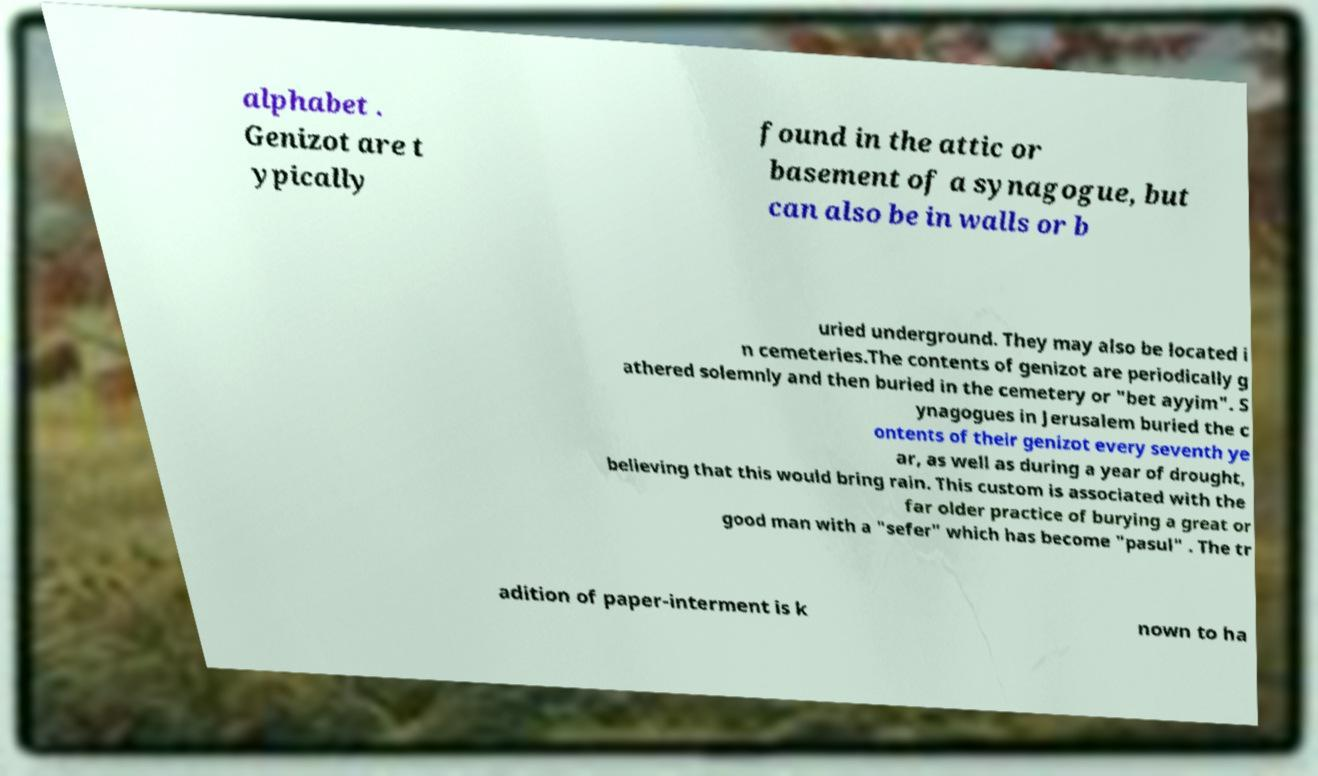Can you accurately transcribe the text from the provided image for me? alphabet . Genizot are t ypically found in the attic or basement of a synagogue, but can also be in walls or b uried underground. They may also be located i n cemeteries.The contents of genizot are periodically g athered solemnly and then buried in the cemetery or "bet ayyim". S ynagogues in Jerusalem buried the c ontents of their genizot every seventh ye ar, as well as during a year of drought, believing that this would bring rain. This custom is associated with the far older practice of burying a great or good man with a "sefer" which has become "pasul" . The tr adition of paper-interment is k nown to ha 